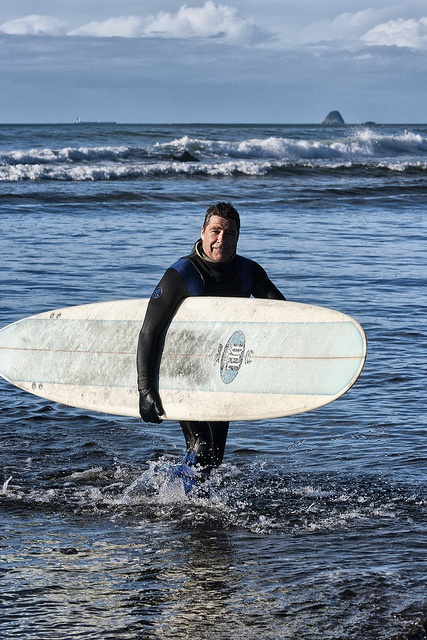Describe the objects in this image and their specific colors. I can see surfboard in darkgray, lightgray, and black tones and people in darkgray, black, lightgray, and gray tones in this image. 